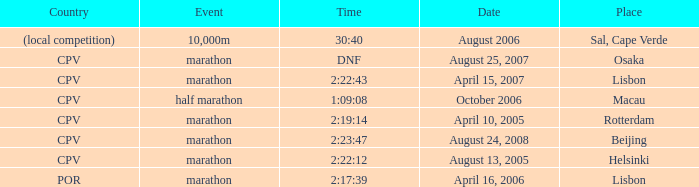What is the location of the event on august 25, 2007? Osaka. 